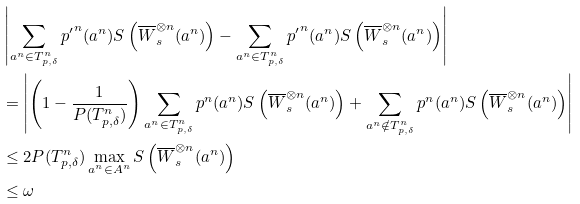Convert formula to latex. <formula><loc_0><loc_0><loc_500><loc_500>& \left | \sum _ { a ^ { n } \in T ^ { n } _ { p , \delta } } { p ^ { \prime } } ^ { n } ( a ^ { n } ) S \left ( \overline { W } _ { s } ^ { \otimes n } ( a ^ { n } ) \right ) - \sum _ { a ^ { n } \in T ^ { n } _ { p , \delta } } { p ^ { \prime } } ^ { n } ( a ^ { n } ) S \left ( \overline { W } _ { s } ^ { \otimes n } ( a ^ { n } ) \right ) \right | \\ & = \left | \left ( 1 - \frac { 1 } { P ( T ^ { n } _ { p , \delta } ) } \right ) \sum _ { a ^ { n } \in T ^ { n } _ { p , \delta } } p ^ { n } ( a ^ { n } ) S \left ( \overline { W } _ { s } ^ { \otimes n } ( a ^ { n } ) \right ) + \sum _ { a ^ { n } \notin T ^ { n } _ { p , \delta } } p ^ { n } ( a ^ { n } ) S \left ( \overline { W } _ { s } ^ { \otimes n } ( a ^ { n } ) \right ) \right | \\ & \leq 2 P ( T ^ { n } _ { p , \delta } ) \max _ { a ^ { n } \in A ^ { n } } S \left ( \overline { W } _ { s } ^ { \otimes n } ( a ^ { n } ) \right ) \\ & \leq \omega</formula> 